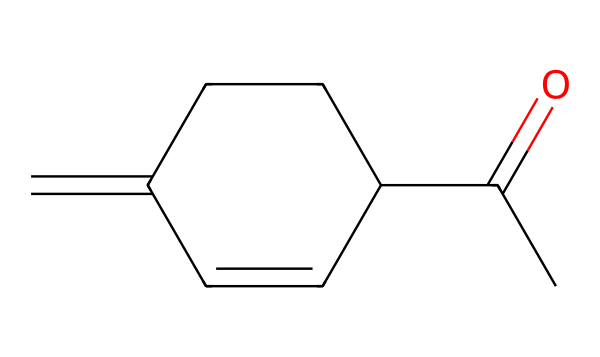What is the molecular formula of jasmone? To determine the molecular formula, we identify the number of each type of atom in the given SMILES representation. In this case, we can count 10 carbon atoms, 14 hydrogen atoms, and 1 oxygen atom. Therefore, the molecular formula is C10H14O.
Answer: C10H14O How many rings are present in the jasmone structure? By analyzing the structure from the SMILES, we can see a cyclic component (denoted by the "C1" and closing "C1"). This indicates the presence of one ring. Thus, there is one ring in the structure.
Answer: one What type of functional group is present in jasmone? The presence of a carbonyl group (C=O), indicated by the "C(=O)" in the SMILES, signifies that this compound is a ketone. Therefore, the functional group is a ketone.
Answer: ketone How many double bonds are present in jasmone? By inspecting the structure, particularly the "=C" notations, we see that there are two carbon-carbon double bonds (in addition to the carbonyl double bond). Therefore, there are two double bonds in total.
Answer: two What is the characteristic scent of jasmone used in? Jasmone is often associated with the scent of jasmine used prominently in perfumes. The use of this compound is primarily for its fragrance contributions.
Answer: perfumes What position does the carbonyl group occupy in jasmone? The carbonyl group is connected to the first carbon in the structure, referred to as the carbonyl carbon, which is also part of a carbon chain. This makes it the first atom in the linear portrayal of the structure.
Answer: first carbon 